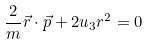<formula> <loc_0><loc_0><loc_500><loc_500>\frac { 2 } { m } \vec { r } \cdot \vec { p } + 2 u _ { 3 } r ^ { 2 } = 0</formula> 